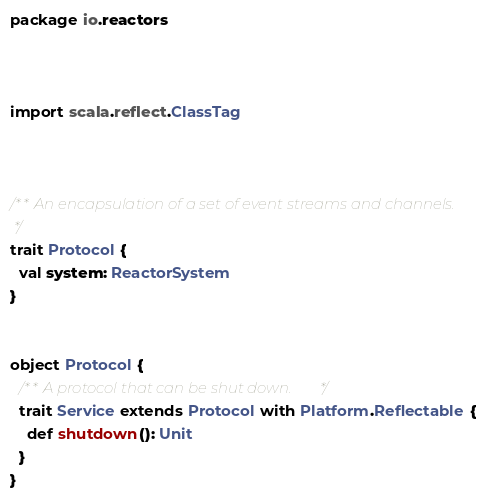<code> <loc_0><loc_0><loc_500><loc_500><_Scala_>package io.reactors



import scala.reflect.ClassTag



/** An encapsulation of a set of event streams and channels.
 */
trait Protocol {
  val system: ReactorSystem
}


object Protocol {
  /** A protocol that can be shut down. */
  trait Service extends Protocol with Platform.Reflectable {
    def shutdown(): Unit
  }
}</code> 